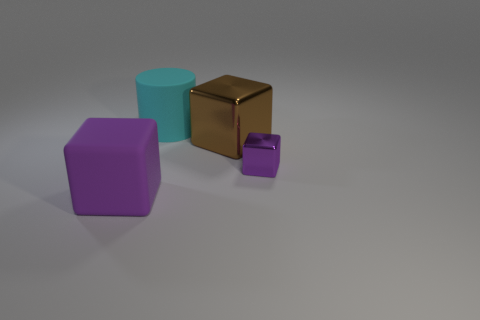Add 1 tiny yellow matte spheres. How many objects exist? 5 Subtract all cylinders. How many objects are left? 3 Subtract all purple things. Subtract all cylinders. How many objects are left? 1 Add 2 cyan matte things. How many cyan matte things are left? 3 Add 3 purple matte things. How many purple matte things exist? 4 Subtract 0 green cylinders. How many objects are left? 4 